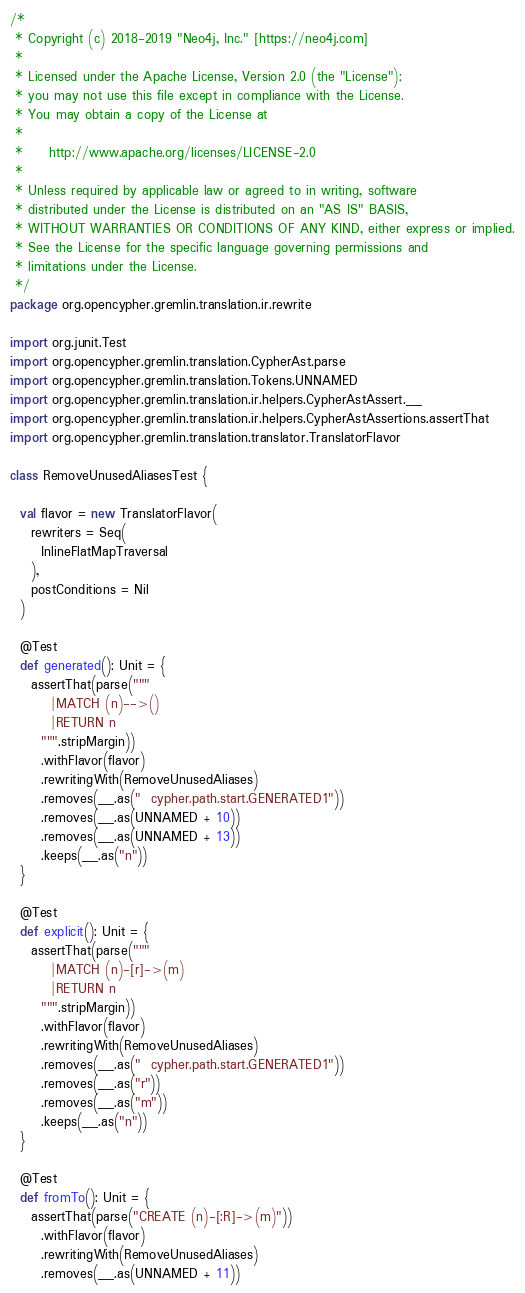<code> <loc_0><loc_0><loc_500><loc_500><_Scala_>/*
 * Copyright (c) 2018-2019 "Neo4j, Inc." [https://neo4j.com]
 *
 * Licensed under the Apache License, Version 2.0 (the "License");
 * you may not use this file except in compliance with the License.
 * You may obtain a copy of the License at
 *
 *     http://www.apache.org/licenses/LICENSE-2.0
 *
 * Unless required by applicable law or agreed to in writing, software
 * distributed under the License is distributed on an "AS IS" BASIS,
 * WITHOUT WARRANTIES OR CONDITIONS OF ANY KIND, either express or implied.
 * See the License for the specific language governing permissions and
 * limitations under the License.
 */
package org.opencypher.gremlin.translation.ir.rewrite

import org.junit.Test
import org.opencypher.gremlin.translation.CypherAst.parse
import org.opencypher.gremlin.translation.Tokens.UNNAMED
import org.opencypher.gremlin.translation.ir.helpers.CypherAstAssert.__
import org.opencypher.gremlin.translation.ir.helpers.CypherAstAssertions.assertThat
import org.opencypher.gremlin.translation.translator.TranslatorFlavor

class RemoveUnusedAliasesTest {

  val flavor = new TranslatorFlavor(
    rewriters = Seq(
      InlineFlatMapTraversal
    ),
    postConditions = Nil
  )

  @Test
  def generated(): Unit = {
    assertThat(parse("""
        |MATCH (n)-->()
        |RETURN n
      """.stripMargin))
      .withFlavor(flavor)
      .rewritingWith(RemoveUnusedAliases)
      .removes(__.as("  cypher.path.start.GENERATED1"))
      .removes(__.as(UNNAMED + 10))
      .removes(__.as(UNNAMED + 13))
      .keeps(__.as("n"))
  }

  @Test
  def explicit(): Unit = {
    assertThat(parse("""
        |MATCH (n)-[r]->(m)
        |RETURN n
      """.stripMargin))
      .withFlavor(flavor)
      .rewritingWith(RemoveUnusedAliases)
      .removes(__.as("  cypher.path.start.GENERATED1"))
      .removes(__.as("r"))
      .removes(__.as("m"))
      .keeps(__.as("n"))
  }

  @Test
  def fromTo(): Unit = {
    assertThat(parse("CREATE (n)-[:R]->(m)"))
      .withFlavor(flavor)
      .rewritingWith(RemoveUnusedAliases)
      .removes(__.as(UNNAMED + 11))</code> 